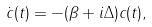Convert formula to latex. <formula><loc_0><loc_0><loc_500><loc_500>\dot { c } ( t ) = - ( \beta + i \Delta ) c ( t ) ,</formula> 